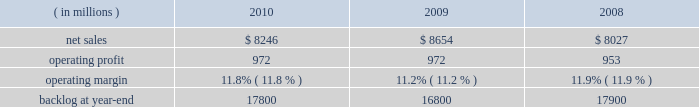Operating profit for the segment decreased by 1% ( 1 % ) in 2010 compared to 2009 .
For the year , operating profit declines in defense more than offset an increase in civil , while operating profit at intelligence essentially was unchanged .
The $ 27 million decrease in operating profit at defense primarily was attributable to a decrease in the level of favorable performance adjustments on mission and combat systems activities in 2010 .
The $ 19 million increase in civil principally was due to higher volume on enterprise civilian services .
Operating profit for the segment decreased by 3% ( 3 % ) in 2009 compared to 2008 .
Operating profit declines in civil and intelligence partially were offset by growth in defense .
The decrease of $ 29 million in civil 2019s operating profit primarily was attributable to a reduction in the level of favorable performance adjustments on enterprise civilian services programs in 2009 compared to 2008 .
The decrease in operating profit of $ 27 million at intelligence mainly was due to a reduction in the level of favorable performance adjustments on security solution activities in 2009 compared to 2008 .
The increase in defense 2019s operating profit of $ 29 million mainly was due to volume and improved performance in mission and combat systems .
The decrease in backlog during 2010 compared to 2009 mainly was due to higher sales volume on enterprise civilian service programs at civil , including volume associated with the dris 2010 program , and mission and combat system programs at defense .
Backlog decreased in 2009 compared to 2008 due to u.s .
Government 2019s exercise of the termination for convenience clause on the tsat mission operations system ( tmos ) contract at defense , which resulted in a $ 1.6 billion reduction in orders .
This decline more than offset increased orders on enterprise civilian services programs at civil .
We expect is&gs will experience a low single digit percentage decrease in sales for 2011 as compared to 2010 .
This decline primarily is due to completion of most of the work associated with the dris 2010 program .
Operating profit in 2011 is expected to decline in relationship to the decline in sales volume , while operating margins are expected to be comparable between the years .
Space systems our space systems business segment is engaged in the design , research and development , engineering , and production of satellites , strategic and defensive missile systems , and space transportation systems , including activities related to the planned replacement of the space shuttle .
Government satellite programs include the advanced extremely high frequency ( aehf ) system , the mobile user objective system ( muos ) , the global positioning satellite iii ( gps iii ) system , the space-based infrared system ( sbirs ) , and the geostationary operational environmental satellite r-series ( goes-r ) .
Strategic and missile defense programs include the targets and countermeasures program and the fleet ballistic missile program .
Space transportation includes the nasa orion program and , through ownership interests in two joint ventures , expendable launch services ( united launch alliance , or ula ) and space shuttle processing activities for the u.s .
Government ( united space alliance , or usa ) .
The space shuttle is expected to complete its final flight mission in 2011 and our involvement with its launch and processing activities will end at that time .
Space systems 2019 operating results included the following : ( in millions ) 2010 2009 2008 .
Net sales for space systems decreased by 5% ( 5 % ) in 2010 compared to 2009 .
Sales declined in all three lines of business during the year .
The $ 253 million decrease in space transportation principally was due to lower volume on the space shuttle external tank , commercial launch vehicle activity and other human space flight programs , which partially were offset by higher volume on the orion program .
There were no commercial launches in 2010 compared to one commercial launch in 2009 .
Strategic & defensive missile systems ( s&dms ) sales declined $ 147 million principally due to lower volume on defensive missile programs .
The $ 8 million sales decline in satellites primarily was attributable to lower volume on commercial satellites , which partially were offset by higher volume on government satellite activities .
There was one commercial satellite delivery in 2010 and one commercial satellite delivery in 2009 .
Net sales for space systems increased 8% ( 8 % ) in 2009 compared to 2008 .
During the year , sales growth at satellites and space transportation offset a decline in s&dms .
The sales growth of $ 707 million in satellites was due to higher volume in government satellite activities , which partially was offset by lower volume in commercial satellite activities .
There was one commercial satellite delivery in 2009 and two deliveries in 2008 .
The increase in sales of $ 21 million in space transportation primarily was due to higher volume on the orion program , which more than offset a decline in the space shuttle 2019s external tank program .
There was one commercial launch in both 2009 and 2008 .
S&dms 2019 sales decreased by $ 102 million mainly due to lower volume on defensive missile programs , which more than offset growth in strategic missile programs. .
What are the total operating expenses as a percentage of sales in 2010? 
Computations: ((8246 - 972) / 8246)
Answer: 0.88212. 